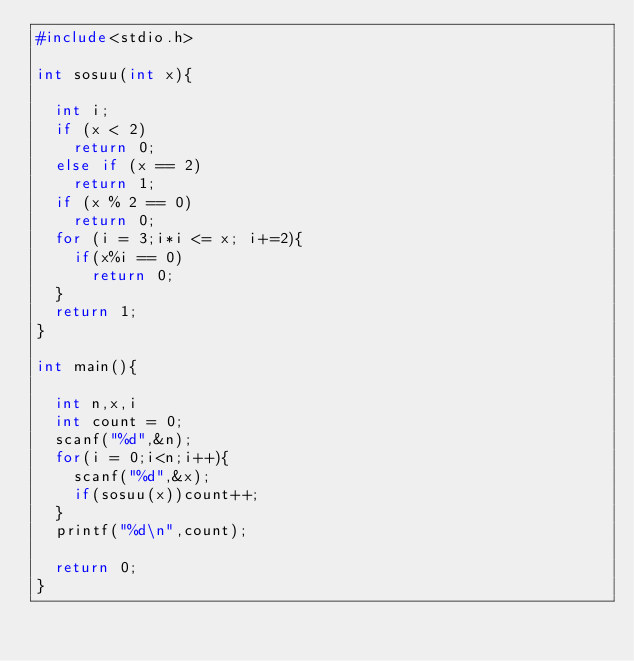<code> <loc_0><loc_0><loc_500><loc_500><_C_>#include<stdio.h>

int sosuu(int x){

  int i;
  if (x < 2)
    return 0;
  else if (x == 2)
    return 1;
  if (x % 2 == 0)
    return 0;
  for (i = 3;i*i <= x; i+=2){
    if(x%i == 0)
      return 0;
  }
  return 1;
}

int main(){

  int n,x,i
  int count = 0;
  scanf("%d",&n);
  for(i = 0;i<n;i++){
    scanf("%d",&x);
    if(sosuu(x))count++;
  }
  printf("%d\n",count);

  return 0;
}
    </code> 